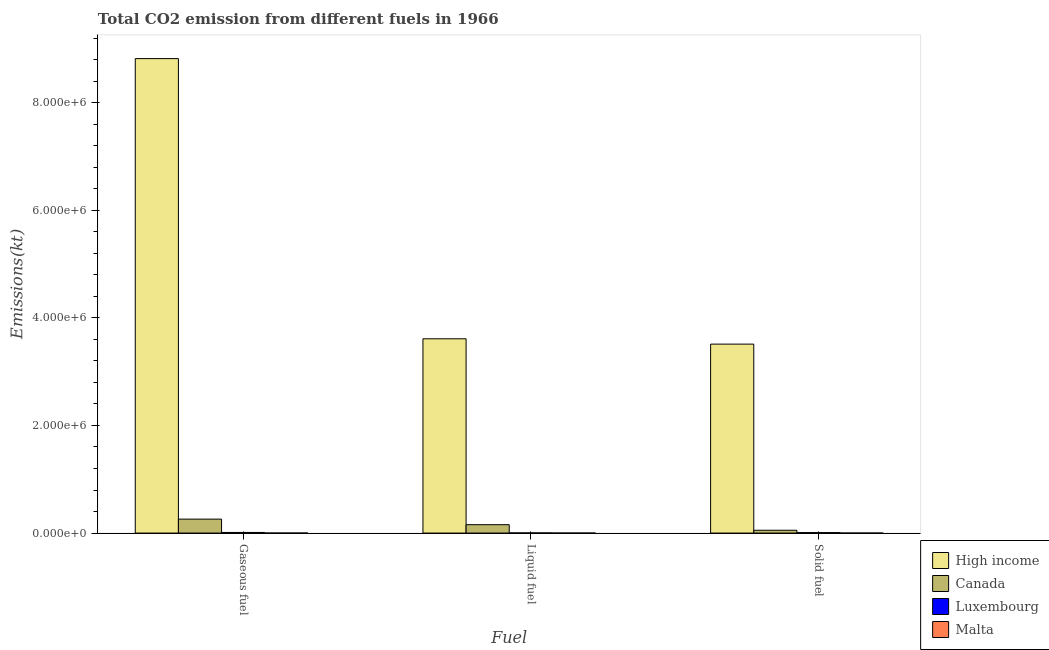How many different coloured bars are there?
Make the answer very short. 4. How many groups of bars are there?
Your response must be concise. 3. Are the number of bars on each tick of the X-axis equal?
Ensure brevity in your answer.  Yes. How many bars are there on the 3rd tick from the right?
Your answer should be compact. 4. What is the label of the 1st group of bars from the left?
Provide a short and direct response. Gaseous fuel. What is the amount of co2 emissions from liquid fuel in High income?
Make the answer very short. 3.61e+06. Across all countries, what is the maximum amount of co2 emissions from solid fuel?
Give a very brief answer. 3.51e+06. Across all countries, what is the minimum amount of co2 emissions from liquid fuel?
Make the answer very short. 407.04. In which country was the amount of co2 emissions from liquid fuel maximum?
Give a very brief answer. High income. In which country was the amount of co2 emissions from gaseous fuel minimum?
Give a very brief answer. Malta. What is the total amount of co2 emissions from liquid fuel in the graph?
Your answer should be compact. 3.77e+06. What is the difference between the amount of co2 emissions from solid fuel in High income and that in Luxembourg?
Offer a very short reply. 3.50e+06. What is the difference between the amount of co2 emissions from liquid fuel in High income and the amount of co2 emissions from gaseous fuel in Luxembourg?
Make the answer very short. 3.60e+06. What is the average amount of co2 emissions from liquid fuel per country?
Offer a terse response. 9.42e+05. What is the difference between the amount of co2 emissions from solid fuel and amount of co2 emissions from gaseous fuel in Malta?
Ensure brevity in your answer.  -407.04. In how many countries, is the amount of co2 emissions from gaseous fuel greater than 4000000 kt?
Your answer should be very brief. 1. What is the ratio of the amount of co2 emissions from gaseous fuel in Canada to that in Luxembourg?
Your response must be concise. 22.32. What is the difference between the highest and the second highest amount of co2 emissions from liquid fuel?
Offer a terse response. 3.45e+06. What is the difference between the highest and the lowest amount of co2 emissions from liquid fuel?
Keep it short and to the point. 3.61e+06. In how many countries, is the amount of co2 emissions from solid fuel greater than the average amount of co2 emissions from solid fuel taken over all countries?
Provide a short and direct response. 1. Is the sum of the amount of co2 emissions from gaseous fuel in Luxembourg and High income greater than the maximum amount of co2 emissions from solid fuel across all countries?
Your answer should be compact. Yes. What does the 2nd bar from the right in Solid fuel represents?
Offer a very short reply. Luxembourg. Is it the case that in every country, the sum of the amount of co2 emissions from gaseous fuel and amount of co2 emissions from liquid fuel is greater than the amount of co2 emissions from solid fuel?
Offer a very short reply. Yes. How many bars are there?
Give a very brief answer. 12. How many countries are there in the graph?
Make the answer very short. 4. What is the difference between two consecutive major ticks on the Y-axis?
Your answer should be very brief. 2.00e+06. Does the graph contain grids?
Offer a terse response. No. What is the title of the graph?
Your response must be concise. Total CO2 emission from different fuels in 1966. Does "Malaysia" appear as one of the legend labels in the graph?
Make the answer very short. No. What is the label or title of the X-axis?
Offer a terse response. Fuel. What is the label or title of the Y-axis?
Offer a terse response. Emissions(kt). What is the Emissions(kt) of High income in Gaseous fuel?
Your answer should be very brief. 8.82e+06. What is the Emissions(kt) in Canada in Gaseous fuel?
Offer a very short reply. 2.59e+05. What is the Emissions(kt) of Luxembourg in Gaseous fuel?
Offer a terse response. 1.16e+04. What is the Emissions(kt) in Malta in Gaseous fuel?
Make the answer very short. 414.37. What is the Emissions(kt) in High income in Liquid fuel?
Offer a terse response. 3.61e+06. What is the Emissions(kt) in Canada in Liquid fuel?
Keep it short and to the point. 1.56e+05. What is the Emissions(kt) in Luxembourg in Liquid fuel?
Your answer should be very brief. 2834.59. What is the Emissions(kt) in Malta in Liquid fuel?
Offer a very short reply. 407.04. What is the Emissions(kt) of High income in Solid fuel?
Provide a short and direct response. 3.51e+06. What is the Emissions(kt) of Canada in Solid fuel?
Provide a succinct answer. 5.26e+04. What is the Emissions(kt) in Luxembourg in Solid fuel?
Offer a terse response. 8672.45. What is the Emissions(kt) of Malta in Solid fuel?
Offer a terse response. 7.33. Across all Fuel, what is the maximum Emissions(kt) in High income?
Provide a succinct answer. 8.82e+06. Across all Fuel, what is the maximum Emissions(kt) of Canada?
Your answer should be very brief. 2.59e+05. Across all Fuel, what is the maximum Emissions(kt) of Luxembourg?
Your answer should be compact. 1.16e+04. Across all Fuel, what is the maximum Emissions(kt) of Malta?
Provide a succinct answer. 414.37. Across all Fuel, what is the minimum Emissions(kt) of High income?
Provide a short and direct response. 3.51e+06. Across all Fuel, what is the minimum Emissions(kt) in Canada?
Give a very brief answer. 5.26e+04. Across all Fuel, what is the minimum Emissions(kt) of Luxembourg?
Keep it short and to the point. 2834.59. Across all Fuel, what is the minimum Emissions(kt) of Malta?
Ensure brevity in your answer.  7.33. What is the total Emissions(kt) in High income in the graph?
Ensure brevity in your answer.  1.59e+07. What is the total Emissions(kt) in Canada in the graph?
Your answer should be very brief. 4.68e+05. What is the total Emissions(kt) of Luxembourg in the graph?
Your answer should be compact. 2.31e+04. What is the total Emissions(kt) of Malta in the graph?
Your answer should be compact. 828.74. What is the difference between the Emissions(kt) of High income in Gaseous fuel and that in Liquid fuel?
Your answer should be very brief. 5.21e+06. What is the difference between the Emissions(kt) of Canada in Gaseous fuel and that in Liquid fuel?
Your response must be concise. 1.03e+05. What is the difference between the Emissions(kt) of Luxembourg in Gaseous fuel and that in Liquid fuel?
Offer a terse response. 8786.13. What is the difference between the Emissions(kt) in Malta in Gaseous fuel and that in Liquid fuel?
Your answer should be very brief. 7.33. What is the difference between the Emissions(kt) of High income in Gaseous fuel and that in Solid fuel?
Keep it short and to the point. 5.31e+06. What is the difference between the Emissions(kt) in Canada in Gaseous fuel and that in Solid fuel?
Give a very brief answer. 2.07e+05. What is the difference between the Emissions(kt) in Luxembourg in Gaseous fuel and that in Solid fuel?
Keep it short and to the point. 2948.27. What is the difference between the Emissions(kt) in Malta in Gaseous fuel and that in Solid fuel?
Offer a very short reply. 407.04. What is the difference between the Emissions(kt) in High income in Liquid fuel and that in Solid fuel?
Make the answer very short. 9.91e+04. What is the difference between the Emissions(kt) of Canada in Liquid fuel and that in Solid fuel?
Offer a very short reply. 1.03e+05. What is the difference between the Emissions(kt) in Luxembourg in Liquid fuel and that in Solid fuel?
Offer a terse response. -5837.86. What is the difference between the Emissions(kt) of Malta in Liquid fuel and that in Solid fuel?
Provide a short and direct response. 399.7. What is the difference between the Emissions(kt) in High income in Gaseous fuel and the Emissions(kt) in Canada in Liquid fuel?
Your response must be concise. 8.66e+06. What is the difference between the Emissions(kt) of High income in Gaseous fuel and the Emissions(kt) of Luxembourg in Liquid fuel?
Your answer should be very brief. 8.81e+06. What is the difference between the Emissions(kt) of High income in Gaseous fuel and the Emissions(kt) of Malta in Liquid fuel?
Ensure brevity in your answer.  8.82e+06. What is the difference between the Emissions(kt) in Canada in Gaseous fuel and the Emissions(kt) in Luxembourg in Liquid fuel?
Your answer should be compact. 2.56e+05. What is the difference between the Emissions(kt) in Canada in Gaseous fuel and the Emissions(kt) in Malta in Liquid fuel?
Keep it short and to the point. 2.59e+05. What is the difference between the Emissions(kt) in Luxembourg in Gaseous fuel and the Emissions(kt) in Malta in Liquid fuel?
Your answer should be very brief. 1.12e+04. What is the difference between the Emissions(kt) in High income in Gaseous fuel and the Emissions(kt) in Canada in Solid fuel?
Provide a succinct answer. 8.76e+06. What is the difference between the Emissions(kt) in High income in Gaseous fuel and the Emissions(kt) in Luxembourg in Solid fuel?
Your response must be concise. 8.81e+06. What is the difference between the Emissions(kt) of High income in Gaseous fuel and the Emissions(kt) of Malta in Solid fuel?
Offer a very short reply. 8.82e+06. What is the difference between the Emissions(kt) of Canada in Gaseous fuel and the Emissions(kt) of Luxembourg in Solid fuel?
Offer a terse response. 2.51e+05. What is the difference between the Emissions(kt) of Canada in Gaseous fuel and the Emissions(kt) of Malta in Solid fuel?
Your answer should be compact. 2.59e+05. What is the difference between the Emissions(kt) in Luxembourg in Gaseous fuel and the Emissions(kt) in Malta in Solid fuel?
Your response must be concise. 1.16e+04. What is the difference between the Emissions(kt) in High income in Liquid fuel and the Emissions(kt) in Canada in Solid fuel?
Ensure brevity in your answer.  3.56e+06. What is the difference between the Emissions(kt) of High income in Liquid fuel and the Emissions(kt) of Luxembourg in Solid fuel?
Provide a succinct answer. 3.60e+06. What is the difference between the Emissions(kt) in High income in Liquid fuel and the Emissions(kt) in Malta in Solid fuel?
Your answer should be compact. 3.61e+06. What is the difference between the Emissions(kt) in Canada in Liquid fuel and the Emissions(kt) in Luxembourg in Solid fuel?
Keep it short and to the point. 1.47e+05. What is the difference between the Emissions(kt) in Canada in Liquid fuel and the Emissions(kt) in Malta in Solid fuel?
Give a very brief answer. 1.56e+05. What is the difference between the Emissions(kt) in Luxembourg in Liquid fuel and the Emissions(kt) in Malta in Solid fuel?
Offer a terse response. 2827.26. What is the average Emissions(kt) of High income per Fuel?
Your answer should be compact. 5.31e+06. What is the average Emissions(kt) of Canada per Fuel?
Ensure brevity in your answer.  1.56e+05. What is the average Emissions(kt) in Luxembourg per Fuel?
Keep it short and to the point. 7709.26. What is the average Emissions(kt) of Malta per Fuel?
Ensure brevity in your answer.  276.25. What is the difference between the Emissions(kt) of High income and Emissions(kt) of Canada in Gaseous fuel?
Ensure brevity in your answer.  8.56e+06. What is the difference between the Emissions(kt) of High income and Emissions(kt) of Luxembourg in Gaseous fuel?
Provide a succinct answer. 8.81e+06. What is the difference between the Emissions(kt) of High income and Emissions(kt) of Malta in Gaseous fuel?
Provide a succinct answer. 8.82e+06. What is the difference between the Emissions(kt) of Canada and Emissions(kt) of Luxembourg in Gaseous fuel?
Give a very brief answer. 2.48e+05. What is the difference between the Emissions(kt) in Canada and Emissions(kt) in Malta in Gaseous fuel?
Your answer should be very brief. 2.59e+05. What is the difference between the Emissions(kt) of Luxembourg and Emissions(kt) of Malta in Gaseous fuel?
Your answer should be very brief. 1.12e+04. What is the difference between the Emissions(kt) of High income and Emissions(kt) of Canada in Liquid fuel?
Ensure brevity in your answer.  3.45e+06. What is the difference between the Emissions(kt) of High income and Emissions(kt) of Luxembourg in Liquid fuel?
Make the answer very short. 3.61e+06. What is the difference between the Emissions(kt) of High income and Emissions(kt) of Malta in Liquid fuel?
Make the answer very short. 3.61e+06. What is the difference between the Emissions(kt) of Canada and Emissions(kt) of Luxembourg in Liquid fuel?
Keep it short and to the point. 1.53e+05. What is the difference between the Emissions(kt) in Canada and Emissions(kt) in Malta in Liquid fuel?
Keep it short and to the point. 1.56e+05. What is the difference between the Emissions(kt) in Luxembourg and Emissions(kt) in Malta in Liquid fuel?
Ensure brevity in your answer.  2427.55. What is the difference between the Emissions(kt) in High income and Emissions(kt) in Canada in Solid fuel?
Provide a short and direct response. 3.46e+06. What is the difference between the Emissions(kt) in High income and Emissions(kt) in Luxembourg in Solid fuel?
Your answer should be compact. 3.50e+06. What is the difference between the Emissions(kt) of High income and Emissions(kt) of Malta in Solid fuel?
Your answer should be compact. 3.51e+06. What is the difference between the Emissions(kt) of Canada and Emissions(kt) of Luxembourg in Solid fuel?
Your answer should be very brief. 4.40e+04. What is the difference between the Emissions(kt) in Canada and Emissions(kt) in Malta in Solid fuel?
Your answer should be compact. 5.26e+04. What is the difference between the Emissions(kt) in Luxembourg and Emissions(kt) in Malta in Solid fuel?
Keep it short and to the point. 8665.12. What is the ratio of the Emissions(kt) in High income in Gaseous fuel to that in Liquid fuel?
Offer a terse response. 2.44. What is the ratio of the Emissions(kt) of Canada in Gaseous fuel to that in Liquid fuel?
Offer a very short reply. 1.66. What is the ratio of the Emissions(kt) of Luxembourg in Gaseous fuel to that in Liquid fuel?
Your response must be concise. 4.1. What is the ratio of the Emissions(kt) in High income in Gaseous fuel to that in Solid fuel?
Offer a very short reply. 2.51. What is the ratio of the Emissions(kt) in Canada in Gaseous fuel to that in Solid fuel?
Your response must be concise. 4.93. What is the ratio of the Emissions(kt) of Luxembourg in Gaseous fuel to that in Solid fuel?
Give a very brief answer. 1.34. What is the ratio of the Emissions(kt) of Malta in Gaseous fuel to that in Solid fuel?
Make the answer very short. 56.5. What is the ratio of the Emissions(kt) in High income in Liquid fuel to that in Solid fuel?
Make the answer very short. 1.03. What is the ratio of the Emissions(kt) in Canada in Liquid fuel to that in Solid fuel?
Keep it short and to the point. 2.96. What is the ratio of the Emissions(kt) in Luxembourg in Liquid fuel to that in Solid fuel?
Make the answer very short. 0.33. What is the ratio of the Emissions(kt) in Malta in Liquid fuel to that in Solid fuel?
Make the answer very short. 55.5. What is the difference between the highest and the second highest Emissions(kt) in High income?
Provide a short and direct response. 5.21e+06. What is the difference between the highest and the second highest Emissions(kt) in Canada?
Provide a short and direct response. 1.03e+05. What is the difference between the highest and the second highest Emissions(kt) of Luxembourg?
Ensure brevity in your answer.  2948.27. What is the difference between the highest and the second highest Emissions(kt) in Malta?
Your answer should be compact. 7.33. What is the difference between the highest and the lowest Emissions(kt) of High income?
Your answer should be compact. 5.31e+06. What is the difference between the highest and the lowest Emissions(kt) of Canada?
Give a very brief answer. 2.07e+05. What is the difference between the highest and the lowest Emissions(kt) in Luxembourg?
Your response must be concise. 8786.13. What is the difference between the highest and the lowest Emissions(kt) in Malta?
Your answer should be compact. 407.04. 